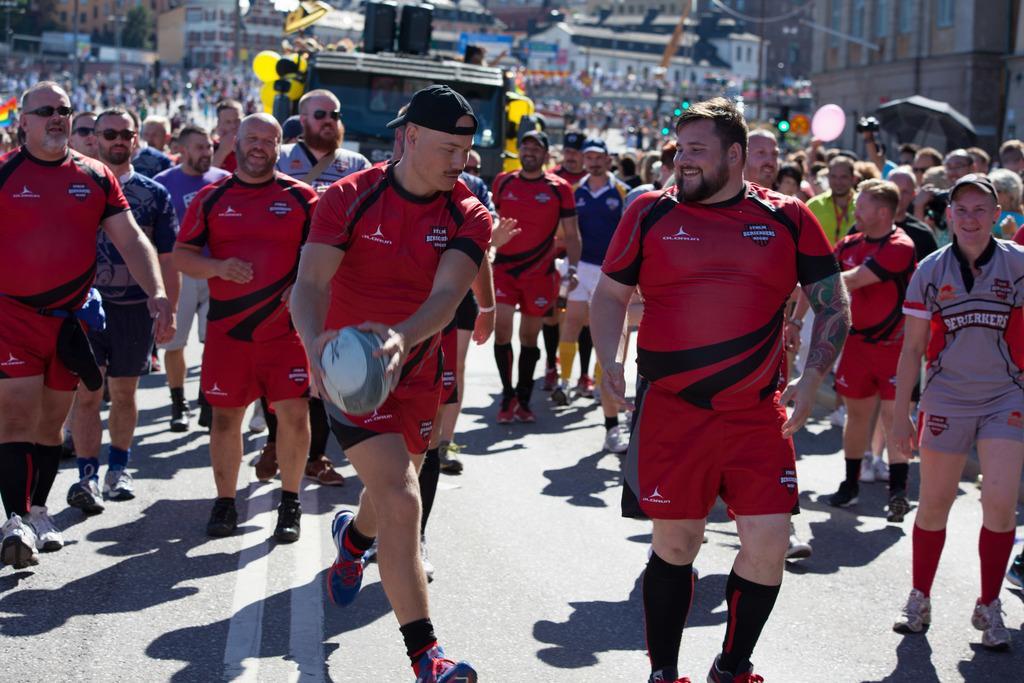Can you describe this image briefly? In the picture I can see a group of people are walking on the road, among them the man in the middle is holding a ball in hands. In the background I can see buildings and some other objects. The background of the image is blurred. 